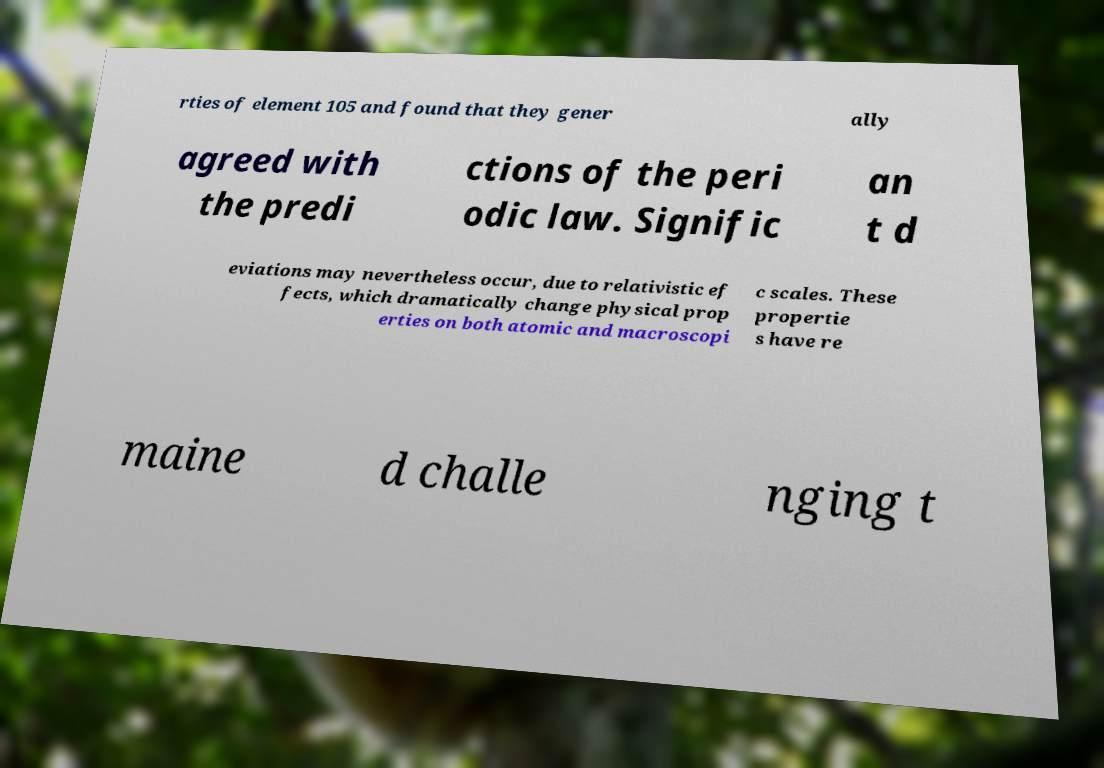Can you accurately transcribe the text from the provided image for me? rties of element 105 and found that they gener ally agreed with the predi ctions of the peri odic law. Signific an t d eviations may nevertheless occur, due to relativistic ef fects, which dramatically change physical prop erties on both atomic and macroscopi c scales. These propertie s have re maine d challe nging t 